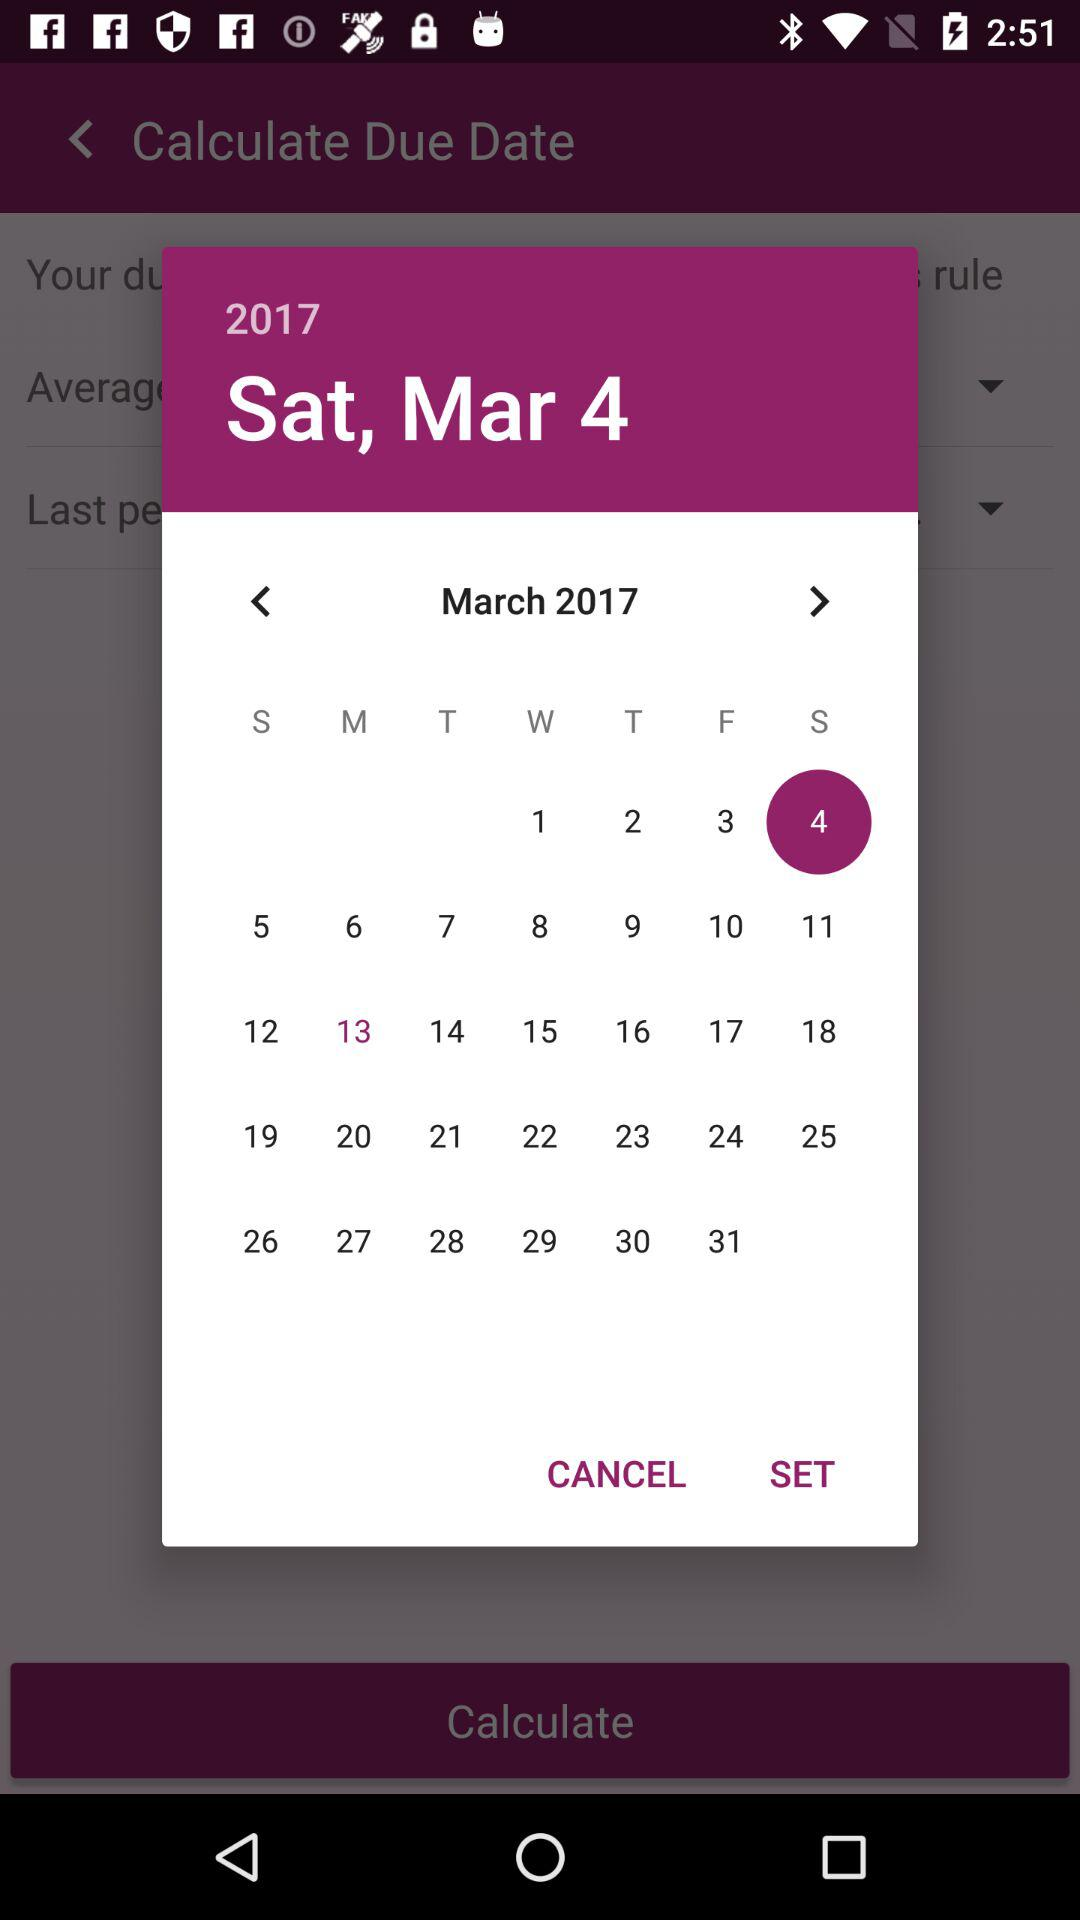Which year of the calendar is shown? The year of the calendar shown is 2017. 